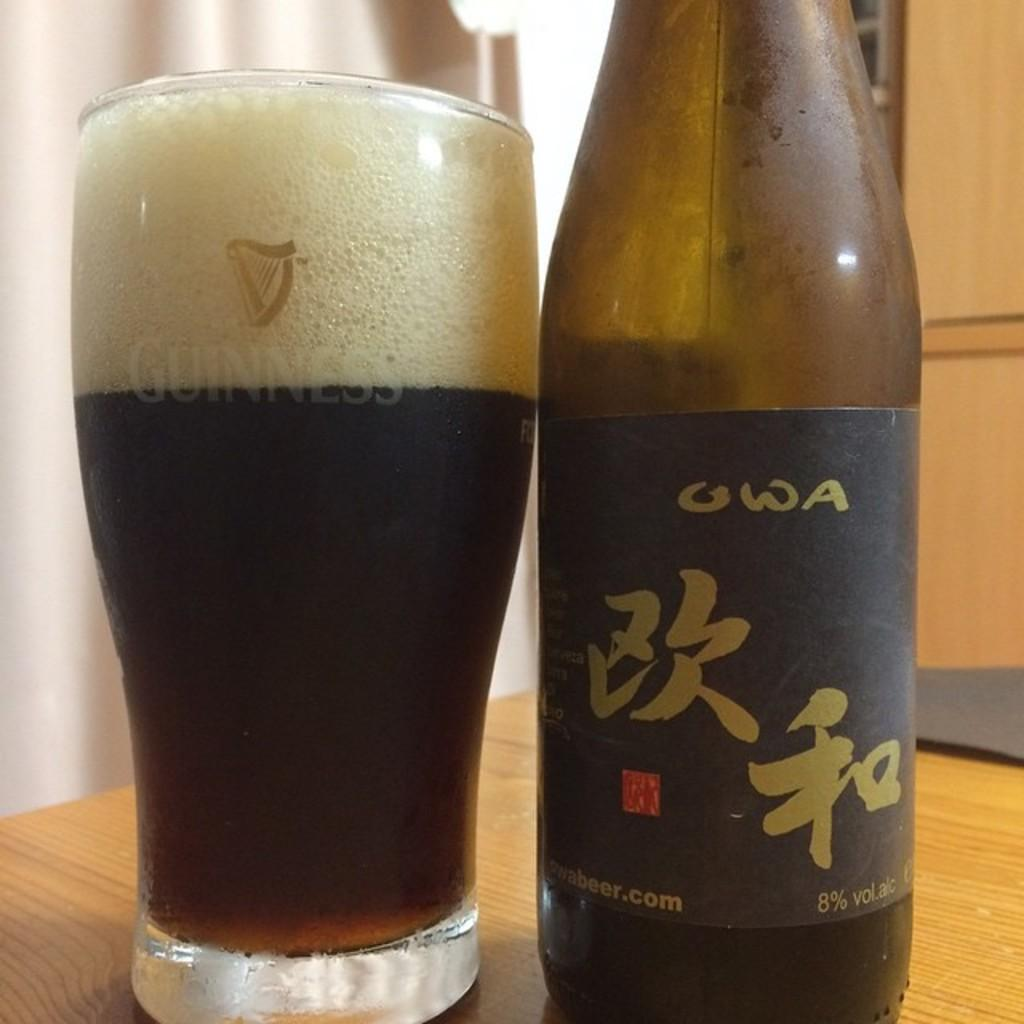<image>
Describe the image concisely. A bottle of beer next to a glass of it, with the letters OWA visible. 